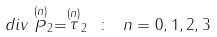Convert formula to latex. <formula><loc_0><loc_0><loc_500><loc_500>d i v \stackrel { ( n ) } { P } _ { 2 } = \stackrel { ( n ) } { \tau } _ { 2 } \ \colon \ n = 0 , 1 , 2 , 3</formula> 